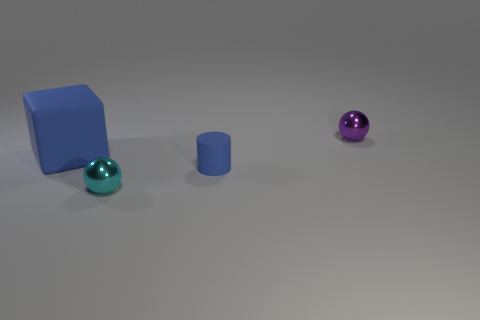There is a small purple object that is the same shape as the tiny cyan thing; what material is it?
Ensure brevity in your answer.  Metal. There is a matte cylinder; is its size the same as the metal object that is in front of the large matte thing?
Give a very brief answer. Yes. What number of small objects are cyan objects or blue spheres?
Your answer should be compact. 1. Are there more small cyan shiny things than large cyan matte cylinders?
Your answer should be compact. Yes. How many tiny balls are to the left of the metal object right of the tiny metal ball that is in front of the small purple metallic sphere?
Your answer should be very brief. 1. The large matte object has what shape?
Provide a succinct answer. Cube. What number of other objects are there of the same material as the tiny blue cylinder?
Offer a terse response. 1. Do the blue cylinder and the cyan metallic ball have the same size?
Your response must be concise. Yes. The matte object on the right side of the block has what shape?
Give a very brief answer. Cylinder. What is the color of the tiny metallic sphere to the left of the ball that is to the right of the blue matte cylinder?
Keep it short and to the point. Cyan. 